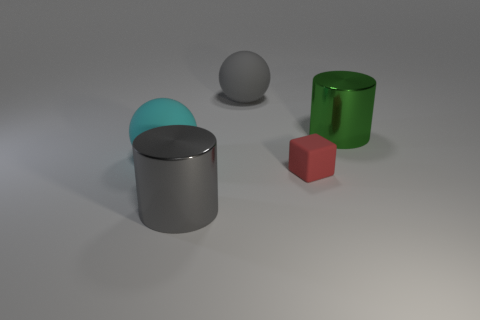Add 5 purple rubber cylinders. How many objects exist? 10 Subtract all green cylinders. How many cylinders are left? 1 Subtract all blocks. How many objects are left? 4 Subtract 2 spheres. How many spheres are left? 0 Add 1 purple cylinders. How many purple cylinders exist? 1 Subtract 0 green balls. How many objects are left? 5 Subtract all gray blocks. Subtract all yellow cylinders. How many blocks are left? 1 Subtract all purple cylinders. How many purple balls are left? 0 Subtract all big gray cylinders. Subtract all tiny red objects. How many objects are left? 3 Add 2 big gray metallic things. How many big gray metallic things are left? 3 